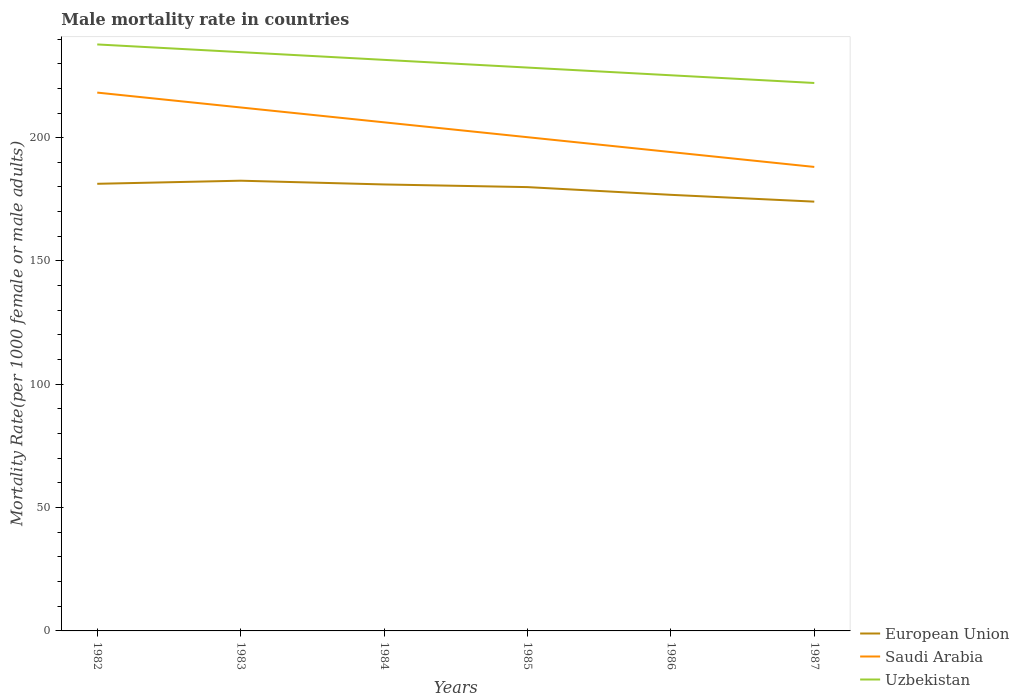How many different coloured lines are there?
Offer a terse response. 3. Is the number of lines equal to the number of legend labels?
Keep it short and to the point. Yes. Across all years, what is the maximum male mortality rate in Saudi Arabia?
Keep it short and to the point. 188.14. In which year was the male mortality rate in European Union maximum?
Your answer should be compact. 1987. What is the total male mortality rate in Uzbekistan in the graph?
Your answer should be very brief. 9.38. What is the difference between the highest and the second highest male mortality rate in Uzbekistan?
Offer a very short reply. 15.63. Is the male mortality rate in European Union strictly greater than the male mortality rate in Uzbekistan over the years?
Keep it short and to the point. Yes. How many lines are there?
Provide a succinct answer. 3. How many years are there in the graph?
Ensure brevity in your answer.  6. Does the graph contain any zero values?
Keep it short and to the point. No. Does the graph contain grids?
Provide a succinct answer. No. How are the legend labels stacked?
Offer a very short reply. Vertical. What is the title of the graph?
Keep it short and to the point. Male mortality rate in countries. Does "Spain" appear as one of the legend labels in the graph?
Keep it short and to the point. No. What is the label or title of the X-axis?
Ensure brevity in your answer.  Years. What is the label or title of the Y-axis?
Make the answer very short. Mortality Rate(per 1000 female or male adults). What is the Mortality Rate(per 1000 female or male adults) of European Union in 1982?
Your answer should be very brief. 181.29. What is the Mortality Rate(per 1000 female or male adults) of Saudi Arabia in 1982?
Offer a very short reply. 218.28. What is the Mortality Rate(per 1000 female or male adults) of Uzbekistan in 1982?
Offer a very short reply. 237.8. What is the Mortality Rate(per 1000 female or male adults) of European Union in 1983?
Offer a terse response. 182.55. What is the Mortality Rate(per 1000 female or male adults) in Saudi Arabia in 1983?
Provide a succinct answer. 212.25. What is the Mortality Rate(per 1000 female or male adults) of Uzbekistan in 1983?
Keep it short and to the point. 234.68. What is the Mortality Rate(per 1000 female or male adults) of European Union in 1984?
Provide a succinct answer. 181.03. What is the Mortality Rate(per 1000 female or male adults) of Saudi Arabia in 1984?
Offer a terse response. 206.22. What is the Mortality Rate(per 1000 female or male adults) in Uzbekistan in 1984?
Give a very brief answer. 231.55. What is the Mortality Rate(per 1000 female or male adults) in European Union in 1985?
Offer a terse response. 179.95. What is the Mortality Rate(per 1000 female or male adults) in Saudi Arabia in 1985?
Ensure brevity in your answer.  200.19. What is the Mortality Rate(per 1000 female or male adults) in Uzbekistan in 1985?
Your answer should be compact. 228.42. What is the Mortality Rate(per 1000 female or male adults) of European Union in 1986?
Make the answer very short. 176.82. What is the Mortality Rate(per 1000 female or male adults) of Saudi Arabia in 1986?
Keep it short and to the point. 194.16. What is the Mortality Rate(per 1000 female or male adults) in Uzbekistan in 1986?
Keep it short and to the point. 225.3. What is the Mortality Rate(per 1000 female or male adults) of European Union in 1987?
Provide a short and direct response. 174.06. What is the Mortality Rate(per 1000 female or male adults) of Saudi Arabia in 1987?
Provide a short and direct response. 188.14. What is the Mortality Rate(per 1000 female or male adults) of Uzbekistan in 1987?
Provide a short and direct response. 222.17. Across all years, what is the maximum Mortality Rate(per 1000 female or male adults) in European Union?
Your response must be concise. 182.55. Across all years, what is the maximum Mortality Rate(per 1000 female or male adults) in Saudi Arabia?
Ensure brevity in your answer.  218.28. Across all years, what is the maximum Mortality Rate(per 1000 female or male adults) of Uzbekistan?
Offer a terse response. 237.8. Across all years, what is the minimum Mortality Rate(per 1000 female or male adults) of European Union?
Your answer should be very brief. 174.06. Across all years, what is the minimum Mortality Rate(per 1000 female or male adults) of Saudi Arabia?
Offer a very short reply. 188.14. Across all years, what is the minimum Mortality Rate(per 1000 female or male adults) of Uzbekistan?
Offer a very short reply. 222.17. What is the total Mortality Rate(per 1000 female or male adults) of European Union in the graph?
Your response must be concise. 1075.71. What is the total Mortality Rate(per 1000 female or male adults) of Saudi Arabia in the graph?
Offer a terse response. 1219.24. What is the total Mortality Rate(per 1000 female or male adults) of Uzbekistan in the graph?
Offer a terse response. 1379.92. What is the difference between the Mortality Rate(per 1000 female or male adults) in European Union in 1982 and that in 1983?
Keep it short and to the point. -1.26. What is the difference between the Mortality Rate(per 1000 female or male adults) in Saudi Arabia in 1982 and that in 1983?
Provide a succinct answer. 6.03. What is the difference between the Mortality Rate(per 1000 female or male adults) in Uzbekistan in 1982 and that in 1983?
Ensure brevity in your answer.  3.13. What is the difference between the Mortality Rate(per 1000 female or male adults) in European Union in 1982 and that in 1984?
Ensure brevity in your answer.  0.27. What is the difference between the Mortality Rate(per 1000 female or male adults) of Saudi Arabia in 1982 and that in 1984?
Offer a very short reply. 12.06. What is the difference between the Mortality Rate(per 1000 female or male adults) of Uzbekistan in 1982 and that in 1984?
Give a very brief answer. 6.25. What is the difference between the Mortality Rate(per 1000 female or male adults) of European Union in 1982 and that in 1985?
Offer a terse response. 1.34. What is the difference between the Mortality Rate(per 1000 female or male adults) in Saudi Arabia in 1982 and that in 1985?
Your answer should be very brief. 18.08. What is the difference between the Mortality Rate(per 1000 female or male adults) in Uzbekistan in 1982 and that in 1985?
Your response must be concise. 9.38. What is the difference between the Mortality Rate(per 1000 female or male adults) of European Union in 1982 and that in 1986?
Your answer should be very brief. 4.47. What is the difference between the Mortality Rate(per 1000 female or male adults) in Saudi Arabia in 1982 and that in 1986?
Make the answer very short. 24.11. What is the difference between the Mortality Rate(per 1000 female or male adults) in Uzbekistan in 1982 and that in 1986?
Provide a short and direct response. 12.5. What is the difference between the Mortality Rate(per 1000 female or male adults) in European Union in 1982 and that in 1987?
Your answer should be very brief. 7.23. What is the difference between the Mortality Rate(per 1000 female or male adults) in Saudi Arabia in 1982 and that in 1987?
Offer a very short reply. 30.14. What is the difference between the Mortality Rate(per 1000 female or male adults) of Uzbekistan in 1982 and that in 1987?
Give a very brief answer. 15.63. What is the difference between the Mortality Rate(per 1000 female or male adults) in European Union in 1983 and that in 1984?
Ensure brevity in your answer.  1.52. What is the difference between the Mortality Rate(per 1000 female or male adults) in Saudi Arabia in 1983 and that in 1984?
Offer a very short reply. 6.03. What is the difference between the Mortality Rate(per 1000 female or male adults) in Uzbekistan in 1983 and that in 1984?
Your response must be concise. 3.13. What is the difference between the Mortality Rate(per 1000 female or male adults) in European Union in 1983 and that in 1985?
Provide a succinct answer. 2.6. What is the difference between the Mortality Rate(per 1000 female or male adults) of Saudi Arabia in 1983 and that in 1985?
Offer a very short reply. 12.06. What is the difference between the Mortality Rate(per 1000 female or male adults) in Uzbekistan in 1983 and that in 1985?
Offer a terse response. 6.25. What is the difference between the Mortality Rate(per 1000 female or male adults) of European Union in 1983 and that in 1986?
Offer a terse response. 5.73. What is the difference between the Mortality Rate(per 1000 female or male adults) of Saudi Arabia in 1983 and that in 1986?
Give a very brief answer. 18.08. What is the difference between the Mortality Rate(per 1000 female or male adults) in Uzbekistan in 1983 and that in 1986?
Give a very brief answer. 9.38. What is the difference between the Mortality Rate(per 1000 female or male adults) in European Union in 1983 and that in 1987?
Give a very brief answer. 8.49. What is the difference between the Mortality Rate(per 1000 female or male adults) of Saudi Arabia in 1983 and that in 1987?
Provide a short and direct response. 24.11. What is the difference between the Mortality Rate(per 1000 female or male adults) in Uzbekistan in 1983 and that in 1987?
Provide a succinct answer. 12.5. What is the difference between the Mortality Rate(per 1000 female or male adults) in European Union in 1984 and that in 1985?
Ensure brevity in your answer.  1.08. What is the difference between the Mortality Rate(per 1000 female or male adults) of Saudi Arabia in 1984 and that in 1985?
Provide a succinct answer. 6.03. What is the difference between the Mortality Rate(per 1000 female or male adults) in Uzbekistan in 1984 and that in 1985?
Offer a terse response. 3.13. What is the difference between the Mortality Rate(per 1000 female or male adults) of European Union in 1984 and that in 1986?
Your answer should be compact. 4.2. What is the difference between the Mortality Rate(per 1000 female or male adults) of Saudi Arabia in 1984 and that in 1986?
Give a very brief answer. 12.06. What is the difference between the Mortality Rate(per 1000 female or male adults) in Uzbekistan in 1984 and that in 1986?
Ensure brevity in your answer.  6.25. What is the difference between the Mortality Rate(per 1000 female or male adults) of European Union in 1984 and that in 1987?
Offer a terse response. 6.97. What is the difference between the Mortality Rate(per 1000 female or male adults) of Saudi Arabia in 1984 and that in 1987?
Keep it short and to the point. 18.08. What is the difference between the Mortality Rate(per 1000 female or male adults) of Uzbekistan in 1984 and that in 1987?
Give a very brief answer. 9.38. What is the difference between the Mortality Rate(per 1000 female or male adults) in European Union in 1985 and that in 1986?
Provide a succinct answer. 3.13. What is the difference between the Mortality Rate(per 1000 female or male adults) of Saudi Arabia in 1985 and that in 1986?
Make the answer very short. 6.03. What is the difference between the Mortality Rate(per 1000 female or male adults) of Uzbekistan in 1985 and that in 1986?
Your answer should be very brief. 3.13. What is the difference between the Mortality Rate(per 1000 female or male adults) in European Union in 1985 and that in 1987?
Your answer should be very brief. 5.89. What is the difference between the Mortality Rate(per 1000 female or male adults) in Saudi Arabia in 1985 and that in 1987?
Keep it short and to the point. 12.06. What is the difference between the Mortality Rate(per 1000 female or male adults) of Uzbekistan in 1985 and that in 1987?
Make the answer very short. 6.25. What is the difference between the Mortality Rate(per 1000 female or male adults) in European Union in 1986 and that in 1987?
Ensure brevity in your answer.  2.76. What is the difference between the Mortality Rate(per 1000 female or male adults) in Saudi Arabia in 1986 and that in 1987?
Ensure brevity in your answer.  6.03. What is the difference between the Mortality Rate(per 1000 female or male adults) in Uzbekistan in 1986 and that in 1987?
Offer a terse response. 3.13. What is the difference between the Mortality Rate(per 1000 female or male adults) in European Union in 1982 and the Mortality Rate(per 1000 female or male adults) in Saudi Arabia in 1983?
Ensure brevity in your answer.  -30.95. What is the difference between the Mortality Rate(per 1000 female or male adults) in European Union in 1982 and the Mortality Rate(per 1000 female or male adults) in Uzbekistan in 1983?
Ensure brevity in your answer.  -53.38. What is the difference between the Mortality Rate(per 1000 female or male adults) of Saudi Arabia in 1982 and the Mortality Rate(per 1000 female or male adults) of Uzbekistan in 1983?
Keep it short and to the point. -16.4. What is the difference between the Mortality Rate(per 1000 female or male adults) of European Union in 1982 and the Mortality Rate(per 1000 female or male adults) of Saudi Arabia in 1984?
Your answer should be compact. -24.93. What is the difference between the Mortality Rate(per 1000 female or male adults) in European Union in 1982 and the Mortality Rate(per 1000 female or male adults) in Uzbekistan in 1984?
Provide a short and direct response. -50.26. What is the difference between the Mortality Rate(per 1000 female or male adults) in Saudi Arabia in 1982 and the Mortality Rate(per 1000 female or male adults) in Uzbekistan in 1984?
Your answer should be compact. -13.27. What is the difference between the Mortality Rate(per 1000 female or male adults) of European Union in 1982 and the Mortality Rate(per 1000 female or male adults) of Saudi Arabia in 1985?
Your answer should be very brief. -18.9. What is the difference between the Mortality Rate(per 1000 female or male adults) in European Union in 1982 and the Mortality Rate(per 1000 female or male adults) in Uzbekistan in 1985?
Keep it short and to the point. -47.13. What is the difference between the Mortality Rate(per 1000 female or male adults) of Saudi Arabia in 1982 and the Mortality Rate(per 1000 female or male adults) of Uzbekistan in 1985?
Your answer should be compact. -10.15. What is the difference between the Mortality Rate(per 1000 female or male adults) of European Union in 1982 and the Mortality Rate(per 1000 female or male adults) of Saudi Arabia in 1986?
Offer a very short reply. -12.87. What is the difference between the Mortality Rate(per 1000 female or male adults) of European Union in 1982 and the Mortality Rate(per 1000 female or male adults) of Uzbekistan in 1986?
Provide a succinct answer. -44.01. What is the difference between the Mortality Rate(per 1000 female or male adults) in Saudi Arabia in 1982 and the Mortality Rate(per 1000 female or male adults) in Uzbekistan in 1986?
Provide a succinct answer. -7.02. What is the difference between the Mortality Rate(per 1000 female or male adults) in European Union in 1982 and the Mortality Rate(per 1000 female or male adults) in Saudi Arabia in 1987?
Make the answer very short. -6.84. What is the difference between the Mortality Rate(per 1000 female or male adults) in European Union in 1982 and the Mortality Rate(per 1000 female or male adults) in Uzbekistan in 1987?
Keep it short and to the point. -40.88. What is the difference between the Mortality Rate(per 1000 female or male adults) of Saudi Arabia in 1982 and the Mortality Rate(per 1000 female or male adults) of Uzbekistan in 1987?
Your response must be concise. -3.9. What is the difference between the Mortality Rate(per 1000 female or male adults) in European Union in 1983 and the Mortality Rate(per 1000 female or male adults) in Saudi Arabia in 1984?
Your answer should be compact. -23.67. What is the difference between the Mortality Rate(per 1000 female or male adults) of European Union in 1983 and the Mortality Rate(per 1000 female or male adults) of Uzbekistan in 1984?
Provide a short and direct response. -49. What is the difference between the Mortality Rate(per 1000 female or male adults) in Saudi Arabia in 1983 and the Mortality Rate(per 1000 female or male adults) in Uzbekistan in 1984?
Offer a very short reply. -19.3. What is the difference between the Mortality Rate(per 1000 female or male adults) in European Union in 1983 and the Mortality Rate(per 1000 female or male adults) in Saudi Arabia in 1985?
Provide a succinct answer. -17.64. What is the difference between the Mortality Rate(per 1000 female or male adults) of European Union in 1983 and the Mortality Rate(per 1000 female or male adults) of Uzbekistan in 1985?
Provide a succinct answer. -45.87. What is the difference between the Mortality Rate(per 1000 female or male adults) of Saudi Arabia in 1983 and the Mortality Rate(per 1000 female or male adults) of Uzbekistan in 1985?
Provide a succinct answer. -16.18. What is the difference between the Mortality Rate(per 1000 female or male adults) of European Union in 1983 and the Mortality Rate(per 1000 female or male adults) of Saudi Arabia in 1986?
Provide a short and direct response. -11.61. What is the difference between the Mortality Rate(per 1000 female or male adults) of European Union in 1983 and the Mortality Rate(per 1000 female or male adults) of Uzbekistan in 1986?
Provide a succinct answer. -42.75. What is the difference between the Mortality Rate(per 1000 female or male adults) of Saudi Arabia in 1983 and the Mortality Rate(per 1000 female or male adults) of Uzbekistan in 1986?
Provide a short and direct response. -13.05. What is the difference between the Mortality Rate(per 1000 female or male adults) of European Union in 1983 and the Mortality Rate(per 1000 female or male adults) of Saudi Arabia in 1987?
Your answer should be compact. -5.58. What is the difference between the Mortality Rate(per 1000 female or male adults) of European Union in 1983 and the Mortality Rate(per 1000 female or male adults) of Uzbekistan in 1987?
Your answer should be very brief. -39.62. What is the difference between the Mortality Rate(per 1000 female or male adults) in Saudi Arabia in 1983 and the Mortality Rate(per 1000 female or male adults) in Uzbekistan in 1987?
Provide a succinct answer. -9.92. What is the difference between the Mortality Rate(per 1000 female or male adults) of European Union in 1984 and the Mortality Rate(per 1000 female or male adults) of Saudi Arabia in 1985?
Your answer should be very brief. -19.17. What is the difference between the Mortality Rate(per 1000 female or male adults) in European Union in 1984 and the Mortality Rate(per 1000 female or male adults) in Uzbekistan in 1985?
Provide a succinct answer. -47.4. What is the difference between the Mortality Rate(per 1000 female or male adults) in Saudi Arabia in 1984 and the Mortality Rate(per 1000 female or male adults) in Uzbekistan in 1985?
Ensure brevity in your answer.  -22.2. What is the difference between the Mortality Rate(per 1000 female or male adults) of European Union in 1984 and the Mortality Rate(per 1000 female or male adults) of Saudi Arabia in 1986?
Offer a terse response. -13.14. What is the difference between the Mortality Rate(per 1000 female or male adults) of European Union in 1984 and the Mortality Rate(per 1000 female or male adults) of Uzbekistan in 1986?
Ensure brevity in your answer.  -44.27. What is the difference between the Mortality Rate(per 1000 female or male adults) in Saudi Arabia in 1984 and the Mortality Rate(per 1000 female or male adults) in Uzbekistan in 1986?
Your answer should be compact. -19.08. What is the difference between the Mortality Rate(per 1000 female or male adults) in European Union in 1984 and the Mortality Rate(per 1000 female or male adults) in Saudi Arabia in 1987?
Provide a succinct answer. -7.11. What is the difference between the Mortality Rate(per 1000 female or male adults) in European Union in 1984 and the Mortality Rate(per 1000 female or male adults) in Uzbekistan in 1987?
Provide a succinct answer. -41.15. What is the difference between the Mortality Rate(per 1000 female or male adults) in Saudi Arabia in 1984 and the Mortality Rate(per 1000 female or male adults) in Uzbekistan in 1987?
Ensure brevity in your answer.  -15.95. What is the difference between the Mortality Rate(per 1000 female or male adults) of European Union in 1985 and the Mortality Rate(per 1000 female or male adults) of Saudi Arabia in 1986?
Make the answer very short. -14.21. What is the difference between the Mortality Rate(per 1000 female or male adults) of European Union in 1985 and the Mortality Rate(per 1000 female or male adults) of Uzbekistan in 1986?
Offer a terse response. -45.35. What is the difference between the Mortality Rate(per 1000 female or male adults) of Saudi Arabia in 1985 and the Mortality Rate(per 1000 female or male adults) of Uzbekistan in 1986?
Your answer should be very brief. -25.11. What is the difference between the Mortality Rate(per 1000 female or male adults) of European Union in 1985 and the Mortality Rate(per 1000 female or male adults) of Saudi Arabia in 1987?
Your response must be concise. -8.19. What is the difference between the Mortality Rate(per 1000 female or male adults) in European Union in 1985 and the Mortality Rate(per 1000 female or male adults) in Uzbekistan in 1987?
Offer a terse response. -42.22. What is the difference between the Mortality Rate(per 1000 female or male adults) of Saudi Arabia in 1985 and the Mortality Rate(per 1000 female or male adults) of Uzbekistan in 1987?
Provide a short and direct response. -21.98. What is the difference between the Mortality Rate(per 1000 female or male adults) of European Union in 1986 and the Mortality Rate(per 1000 female or male adults) of Saudi Arabia in 1987?
Keep it short and to the point. -11.31. What is the difference between the Mortality Rate(per 1000 female or male adults) in European Union in 1986 and the Mortality Rate(per 1000 female or male adults) in Uzbekistan in 1987?
Offer a terse response. -45.35. What is the difference between the Mortality Rate(per 1000 female or male adults) of Saudi Arabia in 1986 and the Mortality Rate(per 1000 female or male adults) of Uzbekistan in 1987?
Give a very brief answer. -28.01. What is the average Mortality Rate(per 1000 female or male adults) of European Union per year?
Make the answer very short. 179.28. What is the average Mortality Rate(per 1000 female or male adults) in Saudi Arabia per year?
Provide a succinct answer. 203.21. What is the average Mortality Rate(per 1000 female or male adults) of Uzbekistan per year?
Your answer should be compact. 229.99. In the year 1982, what is the difference between the Mortality Rate(per 1000 female or male adults) of European Union and Mortality Rate(per 1000 female or male adults) of Saudi Arabia?
Your answer should be compact. -36.98. In the year 1982, what is the difference between the Mortality Rate(per 1000 female or male adults) in European Union and Mortality Rate(per 1000 female or male adults) in Uzbekistan?
Provide a short and direct response. -56.51. In the year 1982, what is the difference between the Mortality Rate(per 1000 female or male adults) in Saudi Arabia and Mortality Rate(per 1000 female or male adults) in Uzbekistan?
Your response must be concise. -19.53. In the year 1983, what is the difference between the Mortality Rate(per 1000 female or male adults) of European Union and Mortality Rate(per 1000 female or male adults) of Saudi Arabia?
Your answer should be very brief. -29.7. In the year 1983, what is the difference between the Mortality Rate(per 1000 female or male adults) of European Union and Mortality Rate(per 1000 female or male adults) of Uzbekistan?
Your answer should be very brief. -52.12. In the year 1983, what is the difference between the Mortality Rate(per 1000 female or male adults) of Saudi Arabia and Mortality Rate(per 1000 female or male adults) of Uzbekistan?
Your answer should be very brief. -22.43. In the year 1984, what is the difference between the Mortality Rate(per 1000 female or male adults) in European Union and Mortality Rate(per 1000 female or male adults) in Saudi Arabia?
Offer a terse response. -25.19. In the year 1984, what is the difference between the Mortality Rate(per 1000 female or male adults) in European Union and Mortality Rate(per 1000 female or male adults) in Uzbekistan?
Provide a short and direct response. -50.52. In the year 1984, what is the difference between the Mortality Rate(per 1000 female or male adults) in Saudi Arabia and Mortality Rate(per 1000 female or male adults) in Uzbekistan?
Your answer should be compact. -25.33. In the year 1985, what is the difference between the Mortality Rate(per 1000 female or male adults) of European Union and Mortality Rate(per 1000 female or male adults) of Saudi Arabia?
Your answer should be compact. -20.24. In the year 1985, what is the difference between the Mortality Rate(per 1000 female or male adults) in European Union and Mortality Rate(per 1000 female or male adults) in Uzbekistan?
Offer a very short reply. -48.47. In the year 1985, what is the difference between the Mortality Rate(per 1000 female or male adults) of Saudi Arabia and Mortality Rate(per 1000 female or male adults) of Uzbekistan?
Offer a terse response. -28.23. In the year 1986, what is the difference between the Mortality Rate(per 1000 female or male adults) of European Union and Mortality Rate(per 1000 female or male adults) of Saudi Arabia?
Give a very brief answer. -17.34. In the year 1986, what is the difference between the Mortality Rate(per 1000 female or male adults) of European Union and Mortality Rate(per 1000 female or male adults) of Uzbekistan?
Your response must be concise. -48.47. In the year 1986, what is the difference between the Mortality Rate(per 1000 female or male adults) in Saudi Arabia and Mortality Rate(per 1000 female or male adults) in Uzbekistan?
Your answer should be compact. -31.13. In the year 1987, what is the difference between the Mortality Rate(per 1000 female or male adults) of European Union and Mortality Rate(per 1000 female or male adults) of Saudi Arabia?
Your answer should be very brief. -14.07. In the year 1987, what is the difference between the Mortality Rate(per 1000 female or male adults) of European Union and Mortality Rate(per 1000 female or male adults) of Uzbekistan?
Your response must be concise. -48.11. In the year 1987, what is the difference between the Mortality Rate(per 1000 female or male adults) in Saudi Arabia and Mortality Rate(per 1000 female or male adults) in Uzbekistan?
Offer a very short reply. -34.04. What is the ratio of the Mortality Rate(per 1000 female or male adults) in Saudi Arabia in 1982 to that in 1983?
Provide a succinct answer. 1.03. What is the ratio of the Mortality Rate(per 1000 female or male adults) of Uzbekistan in 1982 to that in 1983?
Your answer should be very brief. 1.01. What is the ratio of the Mortality Rate(per 1000 female or male adults) in Saudi Arabia in 1982 to that in 1984?
Keep it short and to the point. 1.06. What is the ratio of the Mortality Rate(per 1000 female or male adults) of European Union in 1982 to that in 1985?
Ensure brevity in your answer.  1.01. What is the ratio of the Mortality Rate(per 1000 female or male adults) in Saudi Arabia in 1982 to that in 1985?
Offer a terse response. 1.09. What is the ratio of the Mortality Rate(per 1000 female or male adults) of Uzbekistan in 1982 to that in 1985?
Provide a succinct answer. 1.04. What is the ratio of the Mortality Rate(per 1000 female or male adults) in European Union in 1982 to that in 1986?
Make the answer very short. 1.03. What is the ratio of the Mortality Rate(per 1000 female or male adults) of Saudi Arabia in 1982 to that in 1986?
Your answer should be compact. 1.12. What is the ratio of the Mortality Rate(per 1000 female or male adults) in Uzbekistan in 1982 to that in 1986?
Offer a very short reply. 1.06. What is the ratio of the Mortality Rate(per 1000 female or male adults) in European Union in 1982 to that in 1987?
Keep it short and to the point. 1.04. What is the ratio of the Mortality Rate(per 1000 female or male adults) in Saudi Arabia in 1982 to that in 1987?
Provide a succinct answer. 1.16. What is the ratio of the Mortality Rate(per 1000 female or male adults) of Uzbekistan in 1982 to that in 1987?
Your answer should be very brief. 1.07. What is the ratio of the Mortality Rate(per 1000 female or male adults) in European Union in 1983 to that in 1984?
Offer a terse response. 1.01. What is the ratio of the Mortality Rate(per 1000 female or male adults) in Saudi Arabia in 1983 to that in 1984?
Offer a very short reply. 1.03. What is the ratio of the Mortality Rate(per 1000 female or male adults) in Uzbekistan in 1983 to that in 1984?
Offer a terse response. 1.01. What is the ratio of the Mortality Rate(per 1000 female or male adults) of European Union in 1983 to that in 1985?
Your response must be concise. 1.01. What is the ratio of the Mortality Rate(per 1000 female or male adults) of Saudi Arabia in 1983 to that in 1985?
Give a very brief answer. 1.06. What is the ratio of the Mortality Rate(per 1000 female or male adults) in Uzbekistan in 1983 to that in 1985?
Ensure brevity in your answer.  1.03. What is the ratio of the Mortality Rate(per 1000 female or male adults) in European Union in 1983 to that in 1986?
Your answer should be very brief. 1.03. What is the ratio of the Mortality Rate(per 1000 female or male adults) of Saudi Arabia in 1983 to that in 1986?
Offer a very short reply. 1.09. What is the ratio of the Mortality Rate(per 1000 female or male adults) in Uzbekistan in 1983 to that in 1986?
Your answer should be compact. 1.04. What is the ratio of the Mortality Rate(per 1000 female or male adults) in European Union in 1983 to that in 1987?
Offer a very short reply. 1.05. What is the ratio of the Mortality Rate(per 1000 female or male adults) in Saudi Arabia in 1983 to that in 1987?
Your answer should be very brief. 1.13. What is the ratio of the Mortality Rate(per 1000 female or male adults) of Uzbekistan in 1983 to that in 1987?
Give a very brief answer. 1.06. What is the ratio of the Mortality Rate(per 1000 female or male adults) of European Union in 1984 to that in 1985?
Ensure brevity in your answer.  1.01. What is the ratio of the Mortality Rate(per 1000 female or male adults) of Saudi Arabia in 1984 to that in 1985?
Offer a terse response. 1.03. What is the ratio of the Mortality Rate(per 1000 female or male adults) of Uzbekistan in 1984 to that in 1985?
Offer a terse response. 1.01. What is the ratio of the Mortality Rate(per 1000 female or male adults) of European Union in 1984 to that in 1986?
Ensure brevity in your answer.  1.02. What is the ratio of the Mortality Rate(per 1000 female or male adults) of Saudi Arabia in 1984 to that in 1986?
Keep it short and to the point. 1.06. What is the ratio of the Mortality Rate(per 1000 female or male adults) of Uzbekistan in 1984 to that in 1986?
Provide a short and direct response. 1.03. What is the ratio of the Mortality Rate(per 1000 female or male adults) of European Union in 1984 to that in 1987?
Make the answer very short. 1.04. What is the ratio of the Mortality Rate(per 1000 female or male adults) in Saudi Arabia in 1984 to that in 1987?
Provide a short and direct response. 1.1. What is the ratio of the Mortality Rate(per 1000 female or male adults) in Uzbekistan in 1984 to that in 1987?
Ensure brevity in your answer.  1.04. What is the ratio of the Mortality Rate(per 1000 female or male adults) in European Union in 1985 to that in 1986?
Your response must be concise. 1.02. What is the ratio of the Mortality Rate(per 1000 female or male adults) of Saudi Arabia in 1985 to that in 1986?
Make the answer very short. 1.03. What is the ratio of the Mortality Rate(per 1000 female or male adults) of Uzbekistan in 1985 to that in 1986?
Make the answer very short. 1.01. What is the ratio of the Mortality Rate(per 1000 female or male adults) in European Union in 1985 to that in 1987?
Offer a terse response. 1.03. What is the ratio of the Mortality Rate(per 1000 female or male adults) of Saudi Arabia in 1985 to that in 1987?
Provide a short and direct response. 1.06. What is the ratio of the Mortality Rate(per 1000 female or male adults) in Uzbekistan in 1985 to that in 1987?
Your answer should be very brief. 1.03. What is the ratio of the Mortality Rate(per 1000 female or male adults) of European Union in 1986 to that in 1987?
Give a very brief answer. 1.02. What is the ratio of the Mortality Rate(per 1000 female or male adults) of Saudi Arabia in 1986 to that in 1987?
Make the answer very short. 1.03. What is the ratio of the Mortality Rate(per 1000 female or male adults) of Uzbekistan in 1986 to that in 1987?
Your response must be concise. 1.01. What is the difference between the highest and the second highest Mortality Rate(per 1000 female or male adults) in European Union?
Provide a succinct answer. 1.26. What is the difference between the highest and the second highest Mortality Rate(per 1000 female or male adults) of Saudi Arabia?
Offer a terse response. 6.03. What is the difference between the highest and the second highest Mortality Rate(per 1000 female or male adults) of Uzbekistan?
Make the answer very short. 3.13. What is the difference between the highest and the lowest Mortality Rate(per 1000 female or male adults) in European Union?
Ensure brevity in your answer.  8.49. What is the difference between the highest and the lowest Mortality Rate(per 1000 female or male adults) of Saudi Arabia?
Offer a terse response. 30.14. What is the difference between the highest and the lowest Mortality Rate(per 1000 female or male adults) of Uzbekistan?
Your answer should be very brief. 15.63. 